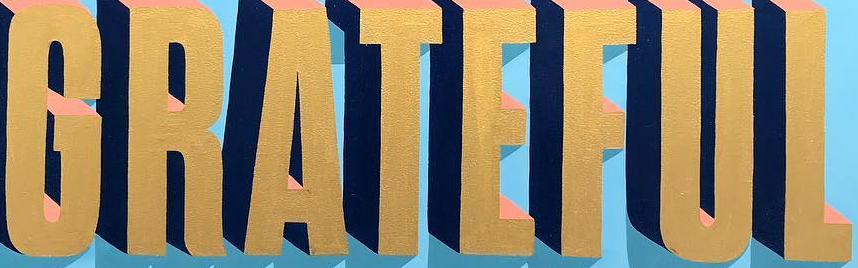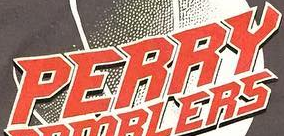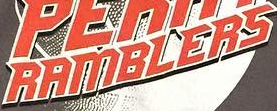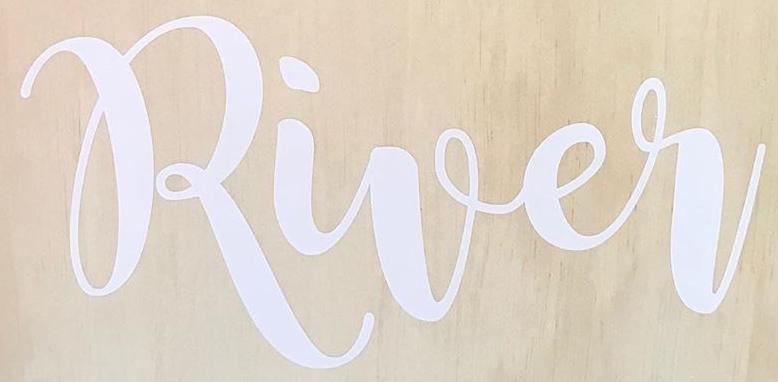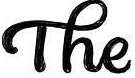Transcribe the words shown in these images in order, separated by a semicolon. GRATEFUL; PERRY; RAMBLERS; River; The 